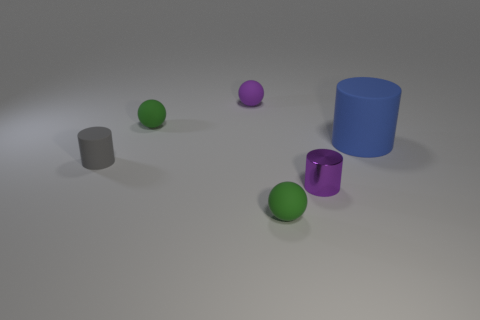Add 3 purple matte balls. How many objects exist? 9 Add 5 purple metallic objects. How many purple metallic objects exist? 6 Subtract 0 cyan balls. How many objects are left? 6 Subtract all large cyan rubber cylinders. Subtract all blue cylinders. How many objects are left? 5 Add 5 large rubber cylinders. How many large rubber cylinders are left? 6 